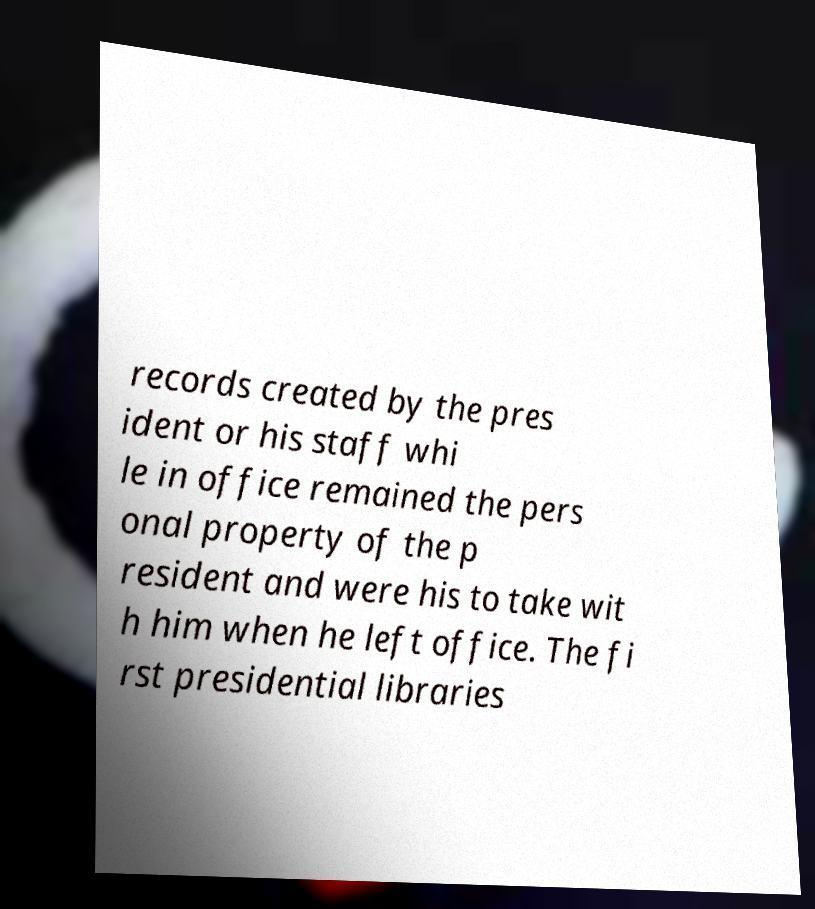Please read and relay the text visible in this image. What does it say? records created by the pres ident or his staff whi le in office remained the pers onal property of the p resident and were his to take wit h him when he left office. The fi rst presidential libraries 